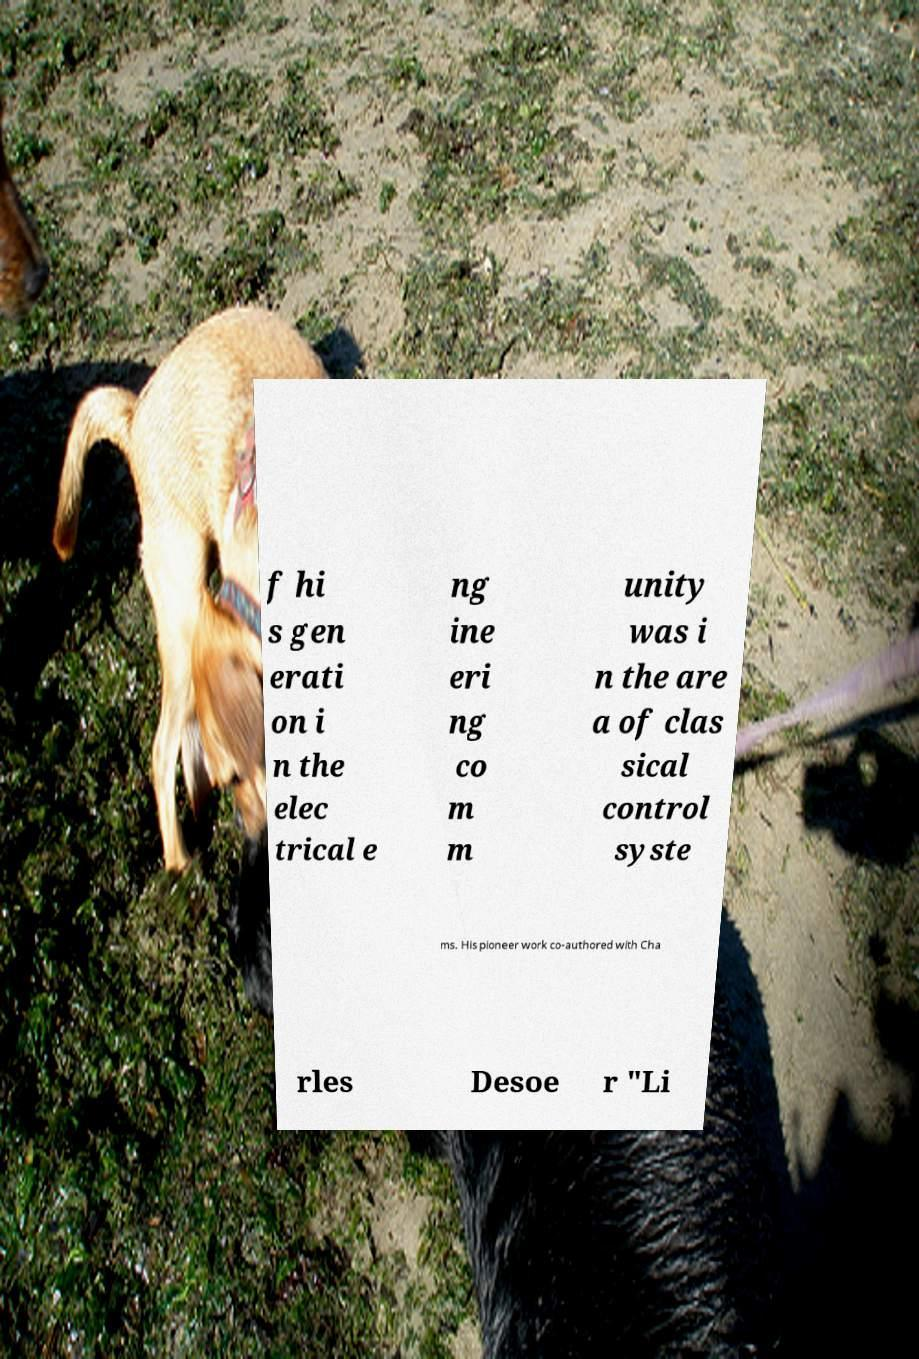Could you assist in decoding the text presented in this image and type it out clearly? f hi s gen erati on i n the elec trical e ng ine eri ng co m m unity was i n the are a of clas sical control syste ms. His pioneer work co-authored with Cha rles Desoe r "Li 